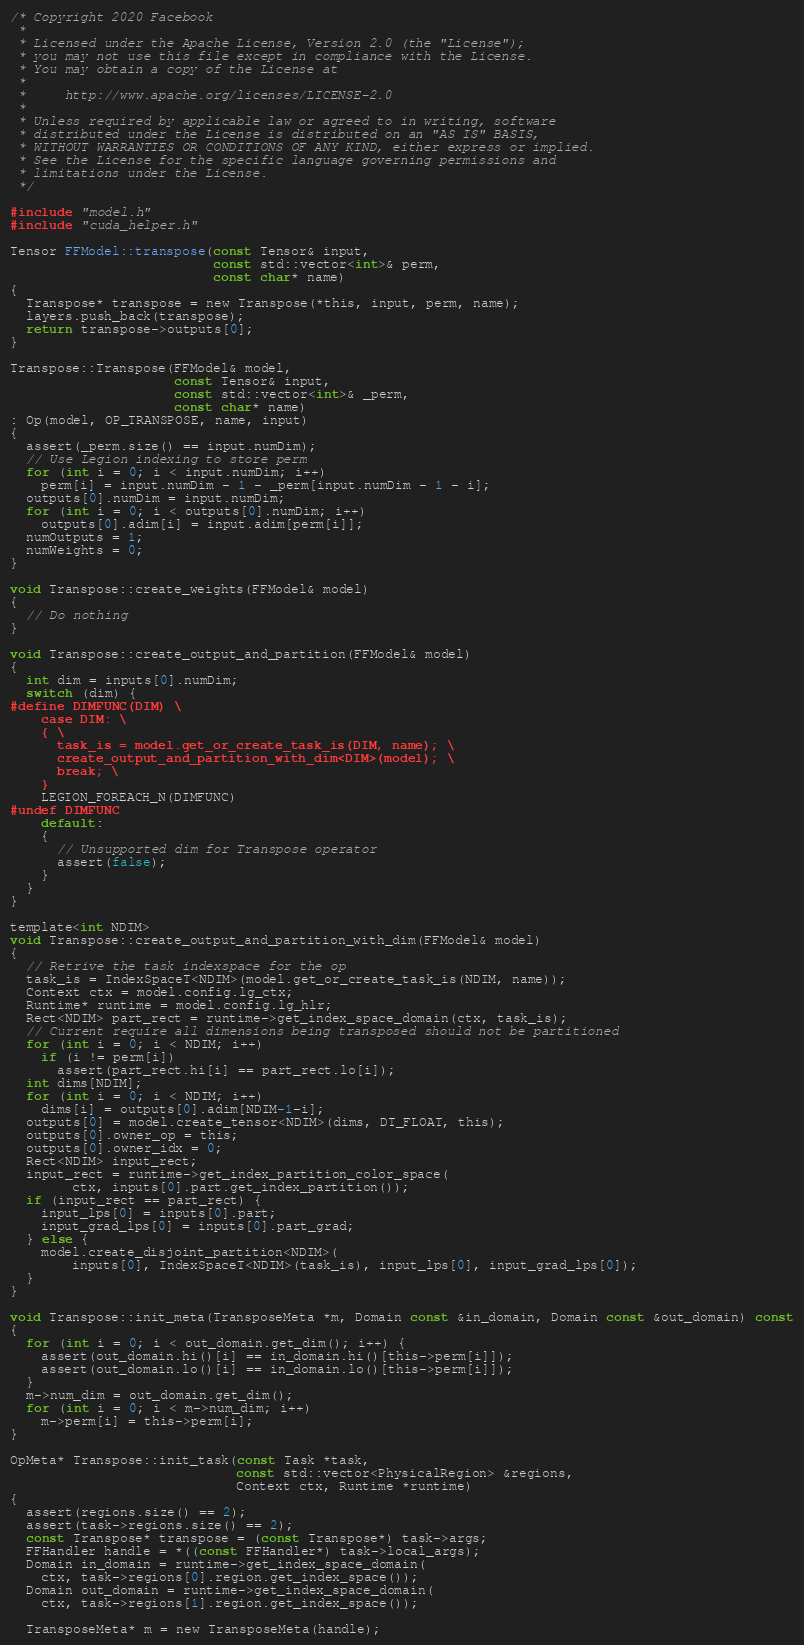Convert code to text. <code><loc_0><loc_0><loc_500><loc_500><_Cuda_>/* Copyright 2020 Facebook
 *
 * Licensed under the Apache License, Version 2.0 (the "License");
 * you may not use this file except in compliance with the License.
 * You may obtain a copy of the License at
 *
 *     http://www.apache.org/licenses/LICENSE-2.0
 *
 * Unless required by applicable law or agreed to in writing, software
 * distributed under the License is distributed on an "AS IS" BASIS,
 * WITHOUT WARRANTIES OR CONDITIONS OF ANY KIND, either express or implied.
 * See the License for the specific language governing permissions and
 * limitations under the License.
 */

#include "model.h"
#include "cuda_helper.h"

Tensor FFModel::transpose(const Tensor& input,
                          const std::vector<int>& perm,
                          const char* name)
{
  Transpose* transpose = new Transpose(*this, input, perm, name);
  layers.push_back(transpose);
  return transpose->outputs[0];
}

Transpose::Transpose(FFModel& model,
                     const Tensor& input,
                     const std::vector<int>& _perm,
                     const char* name)
: Op(model, OP_TRANSPOSE, name, input)
{
  assert(_perm.size() == input.numDim);
  // Use Legion indexing to store perm
  for (int i = 0; i < input.numDim; i++)
    perm[i] = input.numDim - 1 - _perm[input.numDim - 1 - i];
  outputs[0].numDim = input.numDim;
  for (int i = 0; i < outputs[0].numDim; i++)
    outputs[0].adim[i] = input.adim[perm[i]];
  numOutputs = 1;
  numWeights = 0;
}

void Transpose::create_weights(FFModel& model)
{
  // Do nothing
}

void Transpose::create_output_and_partition(FFModel& model)
{
  int dim = inputs[0].numDim;
  switch (dim) {
#define DIMFUNC(DIM) \
    case DIM: \
    { \
      task_is = model.get_or_create_task_is(DIM, name); \
      create_output_and_partition_with_dim<DIM>(model); \
      break; \
    }
    LEGION_FOREACH_N(DIMFUNC)
#undef DIMFUNC
    default:
    {
      // Unsupported dim for Transpose operator
      assert(false);
    }
  }
}

template<int NDIM>
void Transpose::create_output_and_partition_with_dim(FFModel& model)
{
  // Retrive the task indexspace for the op
  task_is = IndexSpaceT<NDIM>(model.get_or_create_task_is(NDIM, name));
  Context ctx = model.config.lg_ctx;
  Runtime* runtime = model.config.lg_hlr;
  Rect<NDIM> part_rect = runtime->get_index_space_domain(ctx, task_is);
  // Current require all dimensions being transposed should not be partitioned
  for (int i = 0; i < NDIM; i++)
    if (i != perm[i])
      assert(part_rect.hi[i] == part_rect.lo[i]);
  int dims[NDIM];
  for (int i = 0; i < NDIM; i++)
    dims[i] = outputs[0].adim[NDIM-1-i];
  outputs[0] = model.create_tensor<NDIM>(dims, DT_FLOAT, this);
  outputs[0].owner_op = this;
  outputs[0].owner_idx = 0;
  Rect<NDIM> input_rect;
  input_rect = runtime->get_index_partition_color_space(
        ctx, inputs[0].part.get_index_partition());
  if (input_rect == part_rect) {
    input_lps[0] = inputs[0].part;
    input_grad_lps[0] = inputs[0].part_grad;
  } else {
    model.create_disjoint_partition<NDIM>(
        inputs[0], IndexSpaceT<NDIM>(task_is), input_lps[0], input_grad_lps[0]);
  }
}

void Transpose::init_meta(TransposeMeta *m, Domain const &in_domain, Domain const &out_domain) const
{
  for (int i = 0; i < out_domain.get_dim(); i++) {
    assert(out_domain.hi()[i] == in_domain.hi()[this->perm[i]]);
    assert(out_domain.lo()[i] == in_domain.lo()[this->perm[i]]);
  }
  m->num_dim = out_domain.get_dim();
  for (int i = 0; i < m->num_dim; i++)
    m->perm[i] = this->perm[i];
}

OpMeta* Transpose::init_task(const Task *task,
                             const std::vector<PhysicalRegion> &regions,
                             Context ctx, Runtime *runtime)
{
  assert(regions.size() == 2);
  assert(task->regions.size() == 2);
  const Transpose* transpose = (const Transpose*) task->args;
  FFHandler handle = *((const FFHandler*) task->local_args);
  Domain in_domain = runtime->get_index_space_domain(
    ctx, task->regions[0].region.get_index_space());
  Domain out_domain = runtime->get_index_space_domain(
    ctx, task->regions[1].region.get_index_space());

  TransposeMeta* m = new TransposeMeta(handle);</code> 